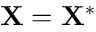Convert formula to latex. <formula><loc_0><loc_0><loc_500><loc_500>X = X ^ { * }</formula> 